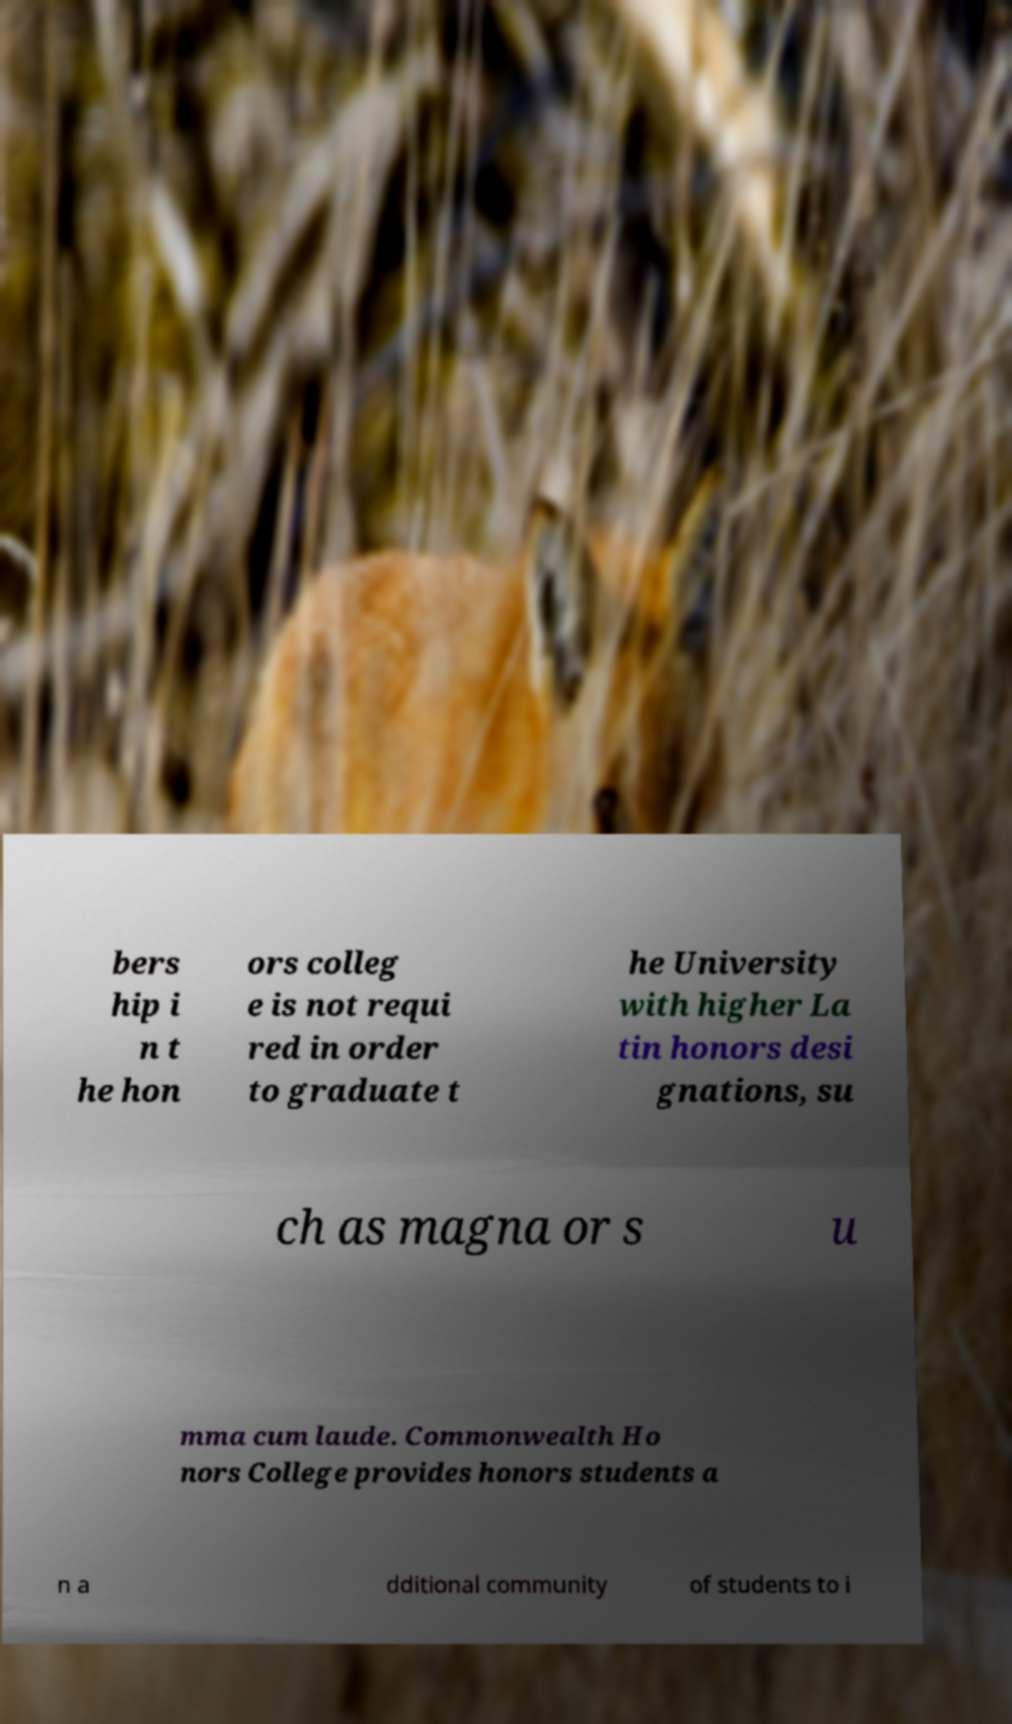Please identify and transcribe the text found in this image. bers hip i n t he hon ors colleg e is not requi red in order to graduate t he University with higher La tin honors desi gnations, su ch as magna or s u mma cum laude. Commonwealth Ho nors College provides honors students a n a dditional community of students to i 